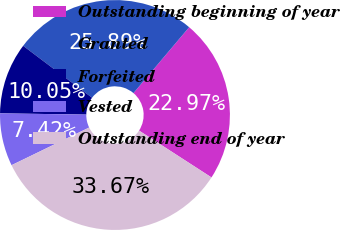<chart> <loc_0><loc_0><loc_500><loc_500><pie_chart><fcel>Outstanding beginning of year<fcel>Granted<fcel>Forfeited<fcel>Vested<fcel>Outstanding end of year<nl><fcel>22.97%<fcel>25.89%<fcel>10.05%<fcel>7.42%<fcel>33.67%<nl></chart> 